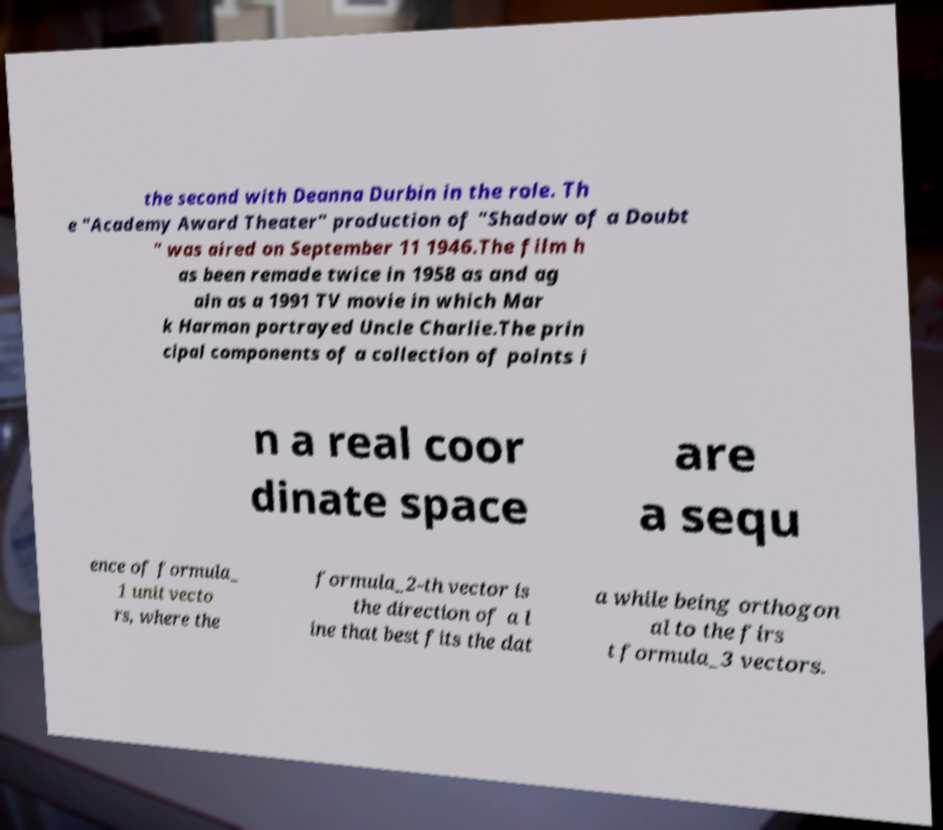For documentation purposes, I need the text within this image transcribed. Could you provide that? the second with Deanna Durbin in the role. Th e "Academy Award Theater" production of "Shadow of a Doubt " was aired on September 11 1946.The film h as been remade twice in 1958 as and ag ain as a 1991 TV movie in which Mar k Harmon portrayed Uncle Charlie.The prin cipal components of a collection of points i n a real coor dinate space are a sequ ence of formula_ 1 unit vecto rs, where the formula_2-th vector is the direction of a l ine that best fits the dat a while being orthogon al to the firs t formula_3 vectors. 